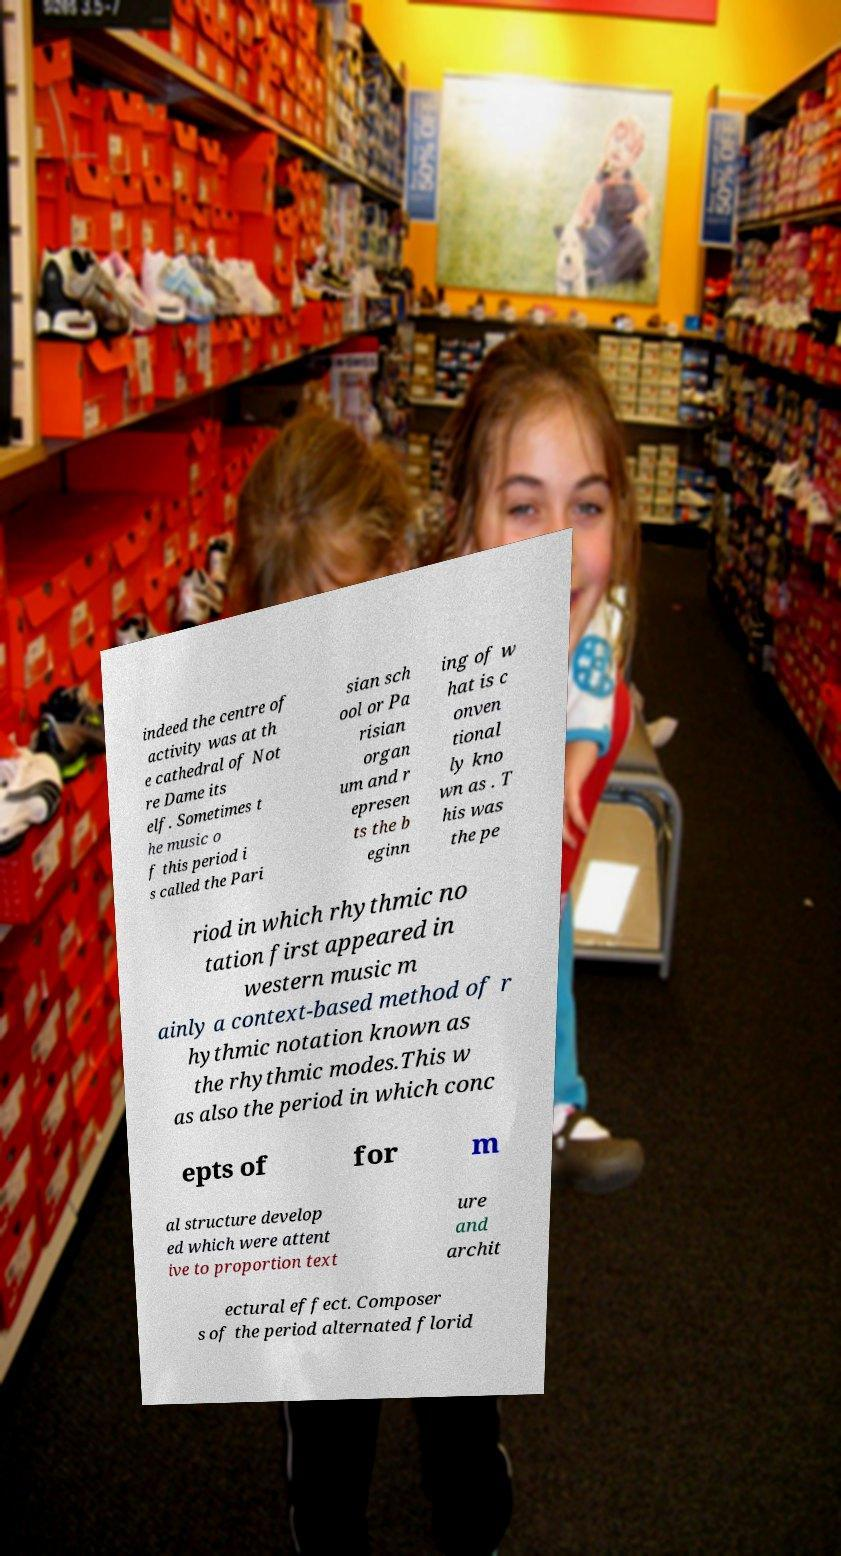I need the written content from this picture converted into text. Can you do that? indeed the centre of activity was at th e cathedral of Not re Dame its elf. Sometimes t he music o f this period i s called the Pari sian sch ool or Pa risian organ um and r epresen ts the b eginn ing of w hat is c onven tional ly kno wn as . T his was the pe riod in which rhythmic no tation first appeared in western music m ainly a context-based method of r hythmic notation known as the rhythmic modes.This w as also the period in which conc epts of for m al structure develop ed which were attent ive to proportion text ure and archit ectural effect. Composer s of the period alternated florid 